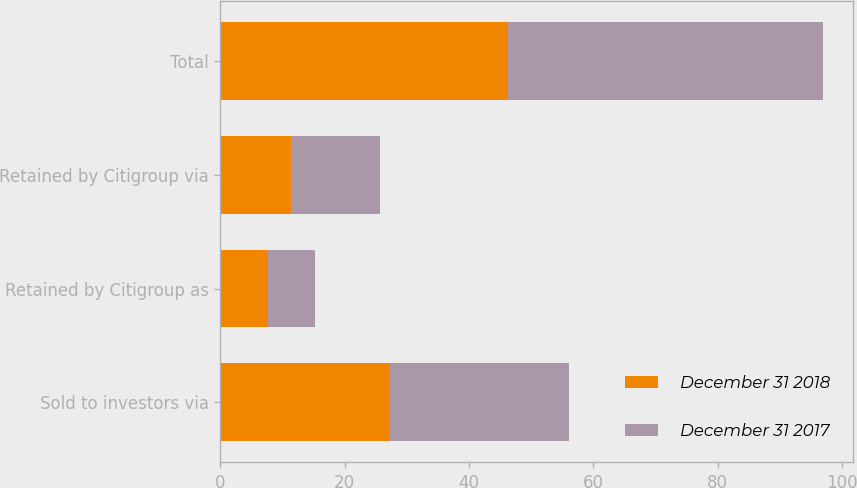Convert chart. <chart><loc_0><loc_0><loc_500><loc_500><stacked_bar_chart><ecel><fcel>Sold to investors via<fcel>Retained by Citigroup as<fcel>Retained by Citigroup via<fcel>Total<nl><fcel>December 31 2018<fcel>27.3<fcel>7.6<fcel>11.3<fcel>46.2<nl><fcel>December 31 2017<fcel>28.8<fcel>7.6<fcel>14.4<fcel>50.8<nl></chart> 